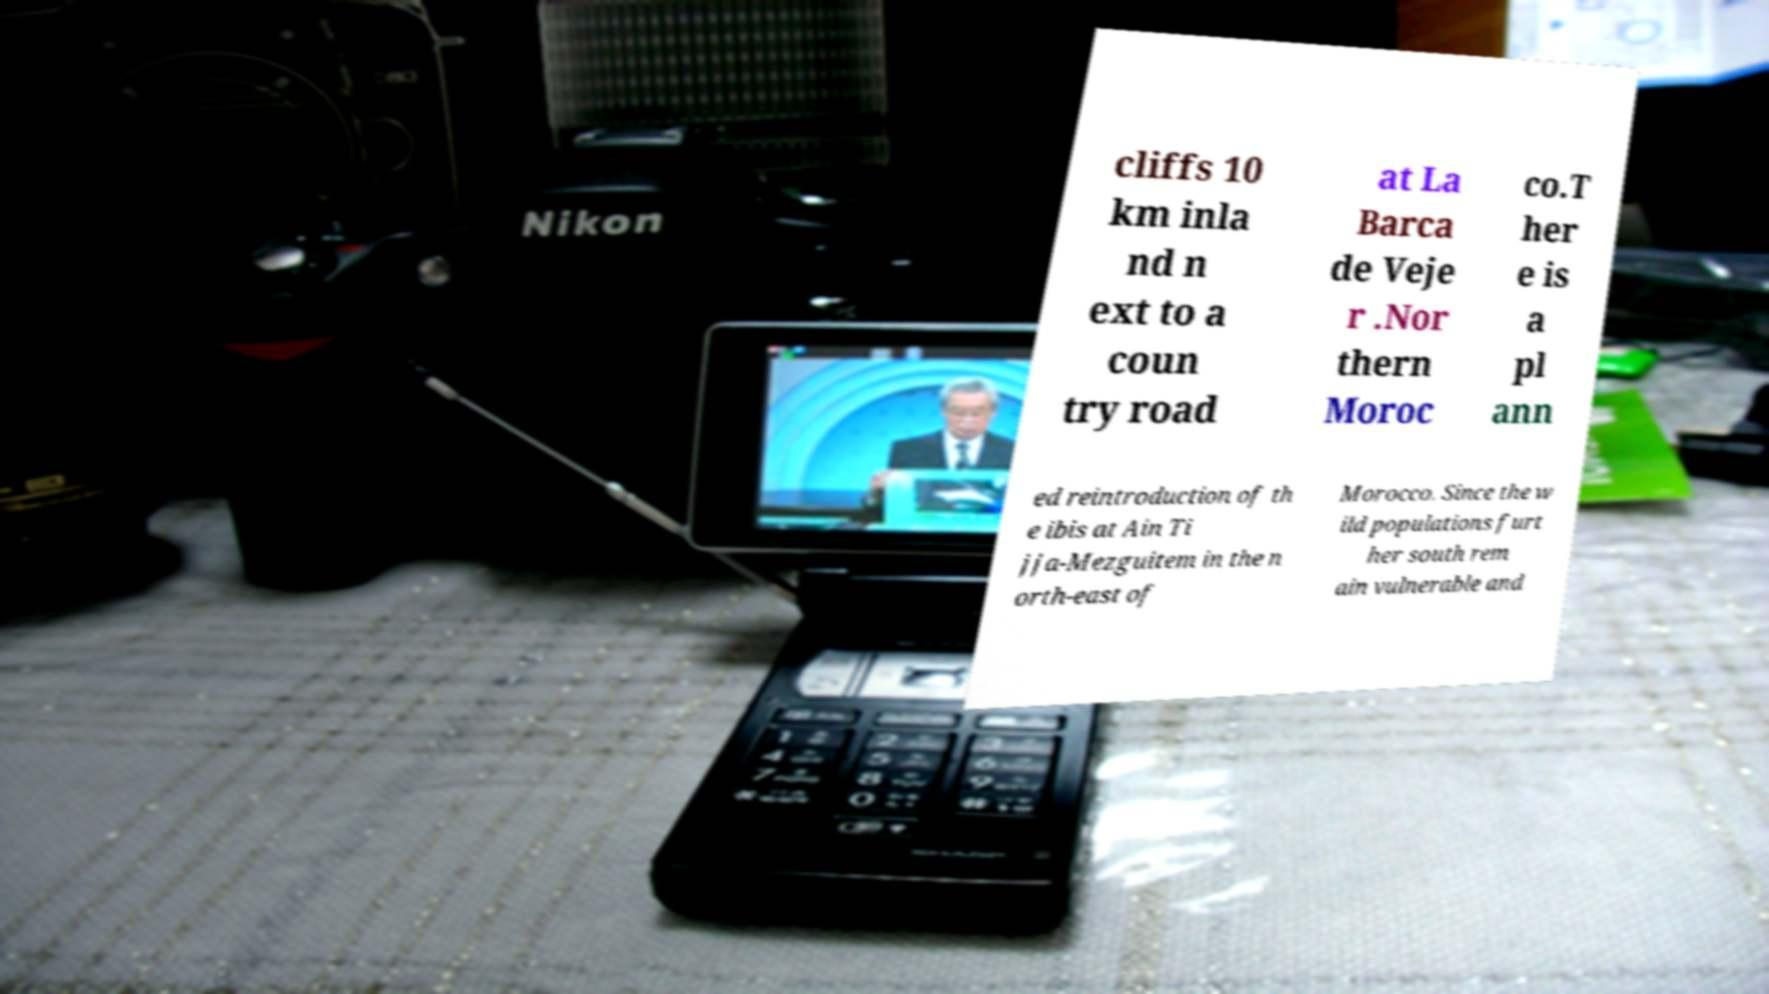I need the written content from this picture converted into text. Can you do that? cliffs 10 km inla nd n ext to a coun try road at La Barca de Veje r .Nor thern Moroc co.T her e is a pl ann ed reintroduction of th e ibis at Ain Ti jja-Mezguitem in the n orth-east of Morocco. Since the w ild populations furt her south rem ain vulnerable and 